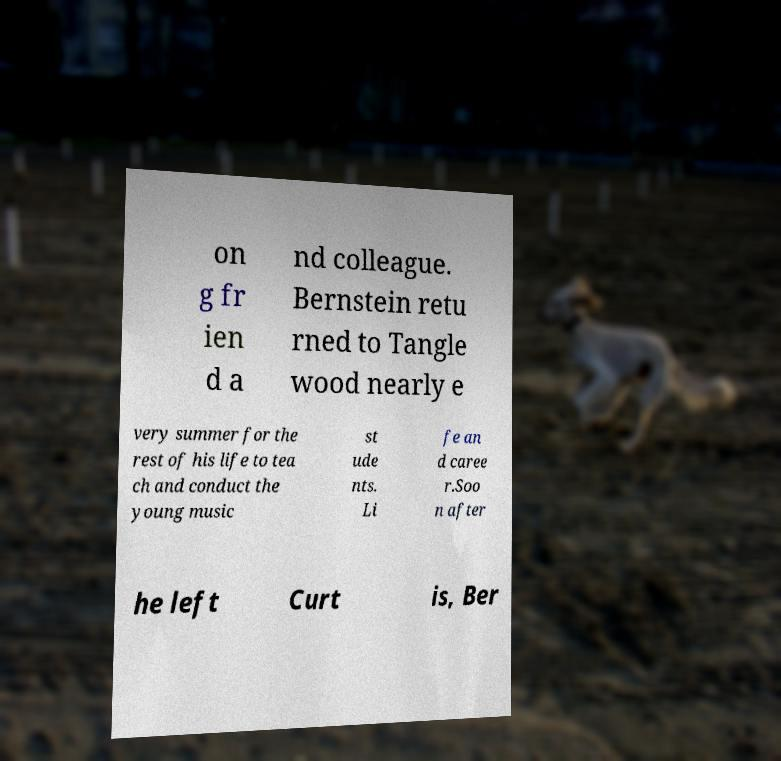Please read and relay the text visible in this image. What does it say? on g fr ien d a nd colleague. Bernstein retu rned to Tangle wood nearly e very summer for the rest of his life to tea ch and conduct the young music st ude nts. Li fe an d caree r.Soo n after he left Curt is, Ber 